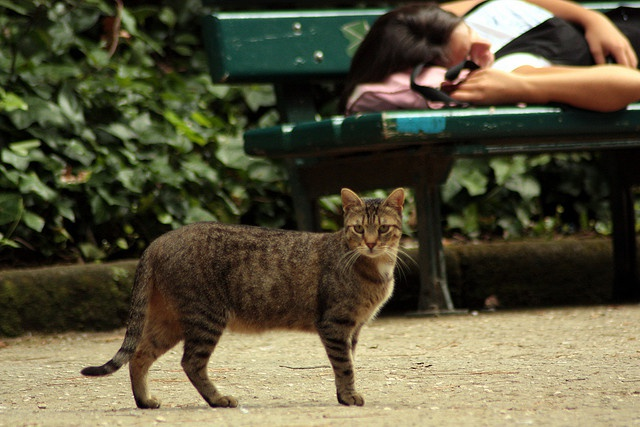Describe the objects in this image and their specific colors. I can see bench in darkgreen, black, and teal tones, cat in darkgreen, black, maroon, and gray tones, people in darkgreen, black, white, maroon, and tan tones, and handbag in darkgreen, black, maroon, lightpink, and brown tones in this image. 